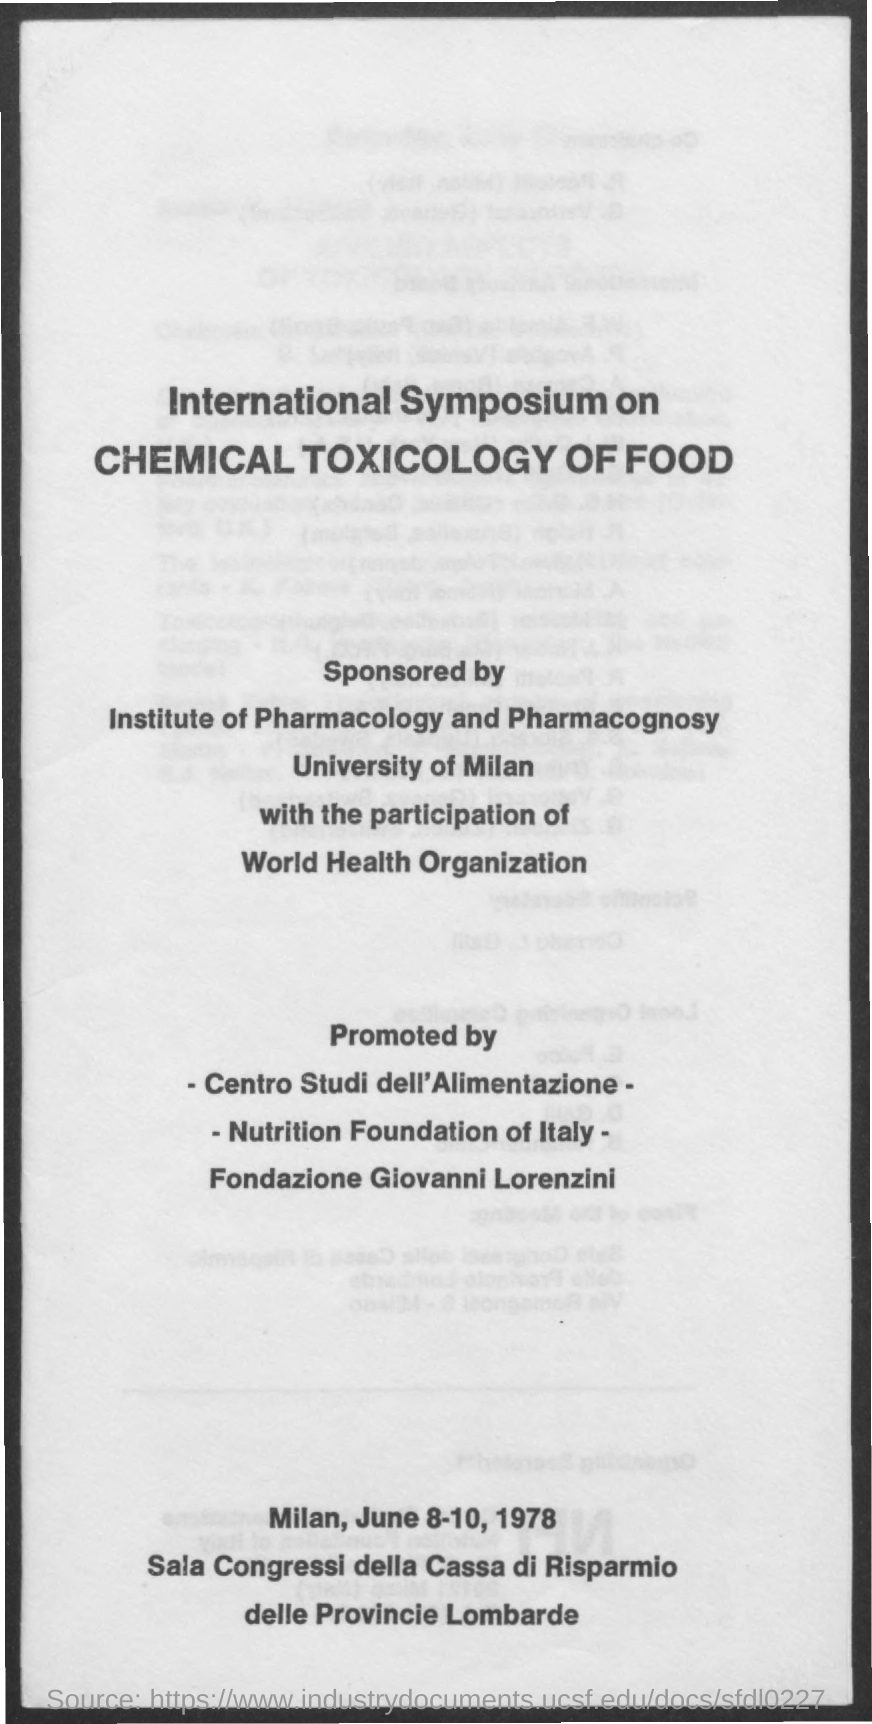Specify some key components in this picture. The Institute of Pharmacology and Pharmacognosy sponsored an international symposium on chemical toxicology of food. The International Symposium on Chemical Toxicology of Food is an event that focuses on the study of the harmful effects of chemicals in food on human health. 